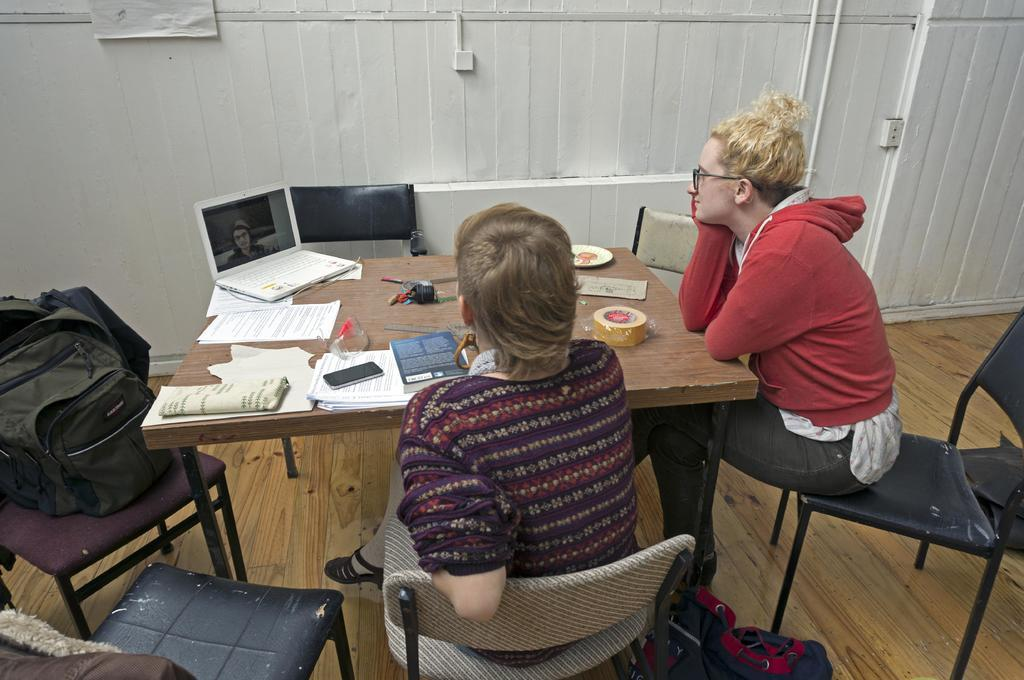How many people are sitting on the chair in the image? There are two persons sitting on a chair in the image. What objects can be seen on the table in the image? There is a tape, a plate, a laptop, papers, a mobile, a book, and a pouch on the table in the image. What is placed on the chair besides the two persons? There is a bag on the chair. What type of fruit can be seen growing near the seashore in the image? There is no seashore or fruit present in the image; it features two persons sitting on a chair and various objects on a table. 